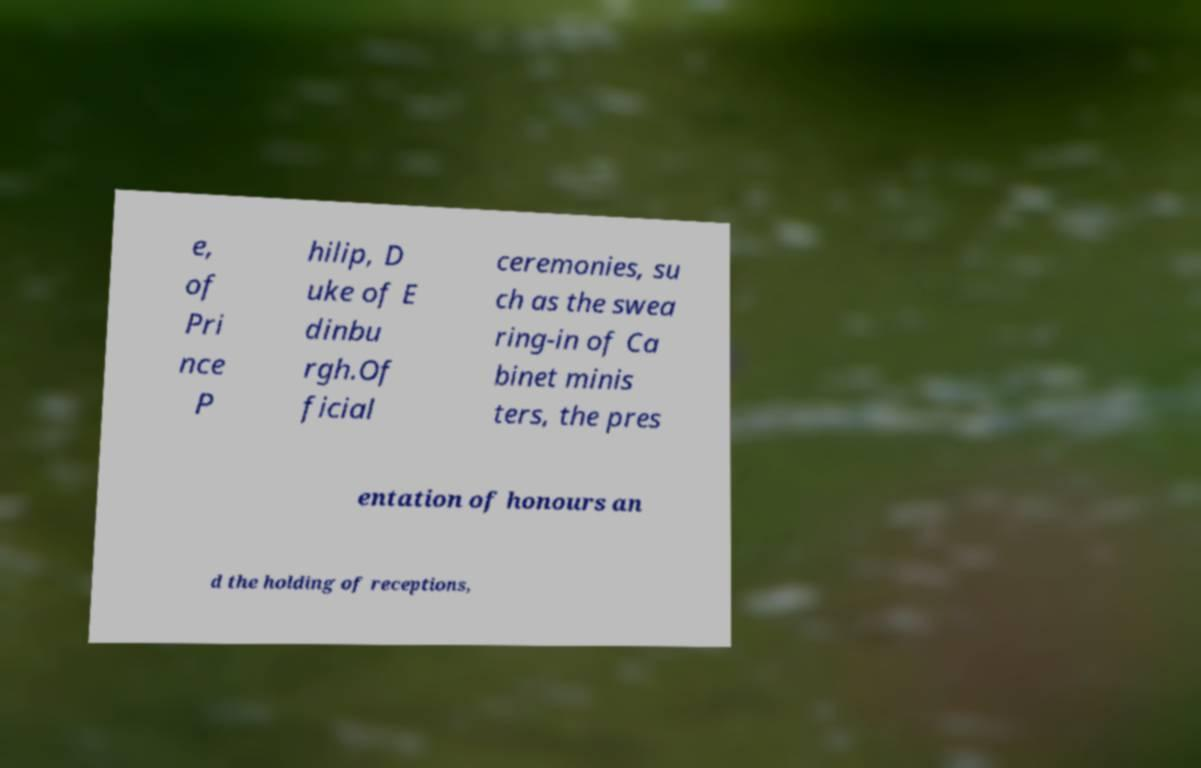There's text embedded in this image that I need extracted. Can you transcribe it verbatim? e, of Pri nce P hilip, D uke of E dinbu rgh.Of ficial ceremonies, su ch as the swea ring-in of Ca binet minis ters, the pres entation of honours an d the holding of receptions, 